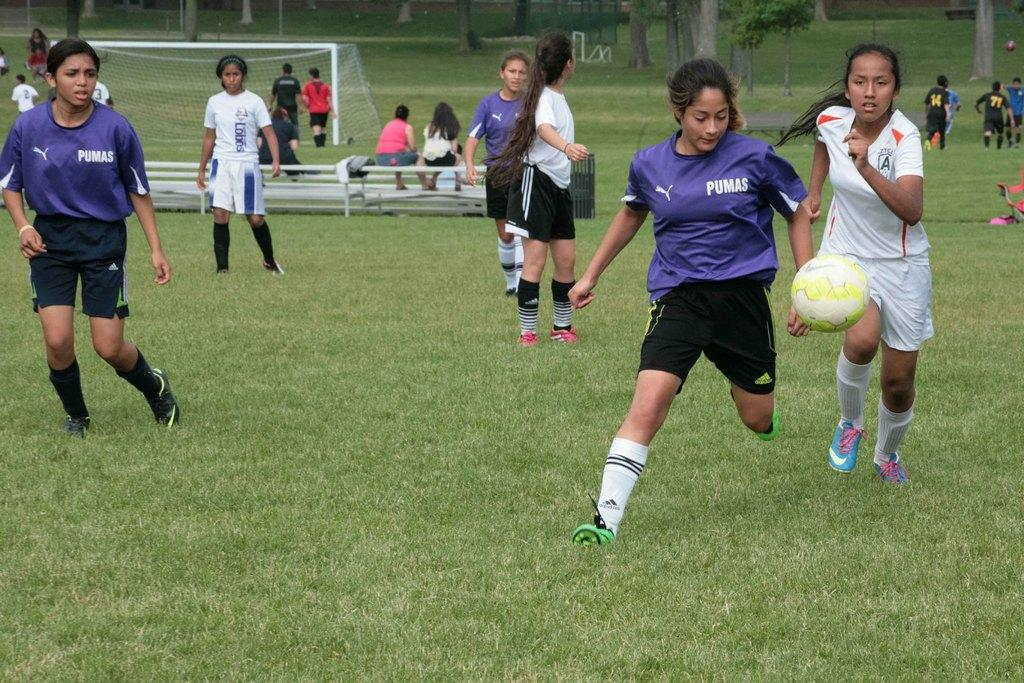<image>
Relay a brief, clear account of the picture shown. the purple soccer team is wearing Pumas jersey 